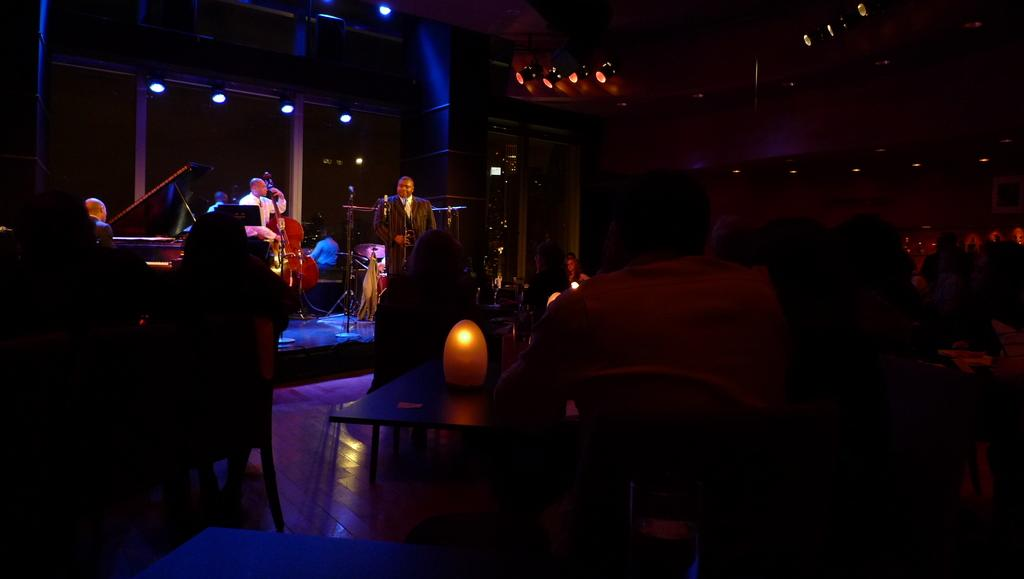What are the people in the image doing? The people in the image are playing musical instruments. What type of furniture is present in the image? There are tables and chairs in the image. What can be seen at the top of the image? There are lights visible at the top of the image. What type of fear can be seen on the toes of the people in the image? There is no indication of fear or toes in the image; the people are playing musical instruments. What type of yam is being served on the tables in the image? There is no yam present in the image; the tables are not shown to have any food items. 